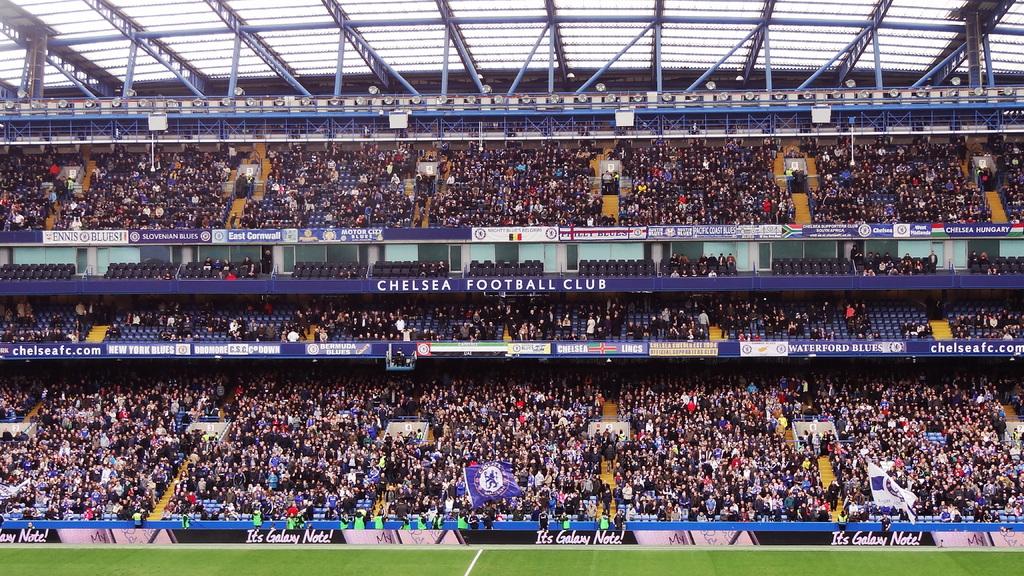Which football club is sponsoring?
Your answer should be compact. Chelsea. 